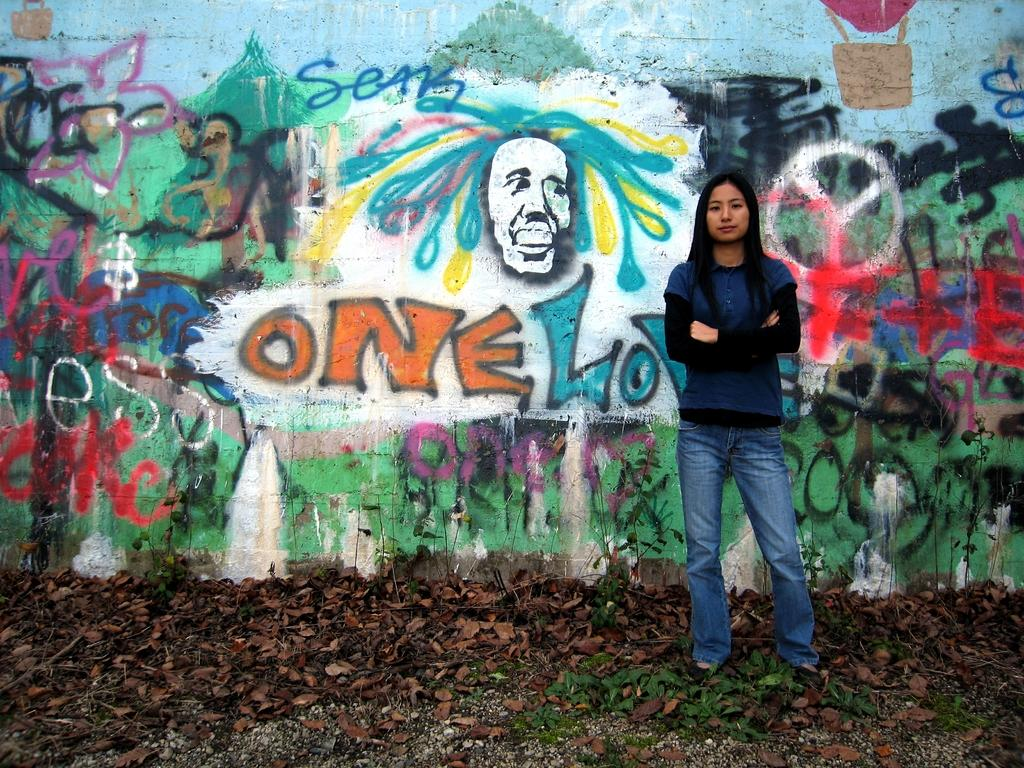What is the main subject in the image? There is a lady standing in the image. What can be seen in the background of the image? There is graffiti on a wall in the background of the image. What type of natural elements are present on the ground in the image? There are leaves on the ground in the image. What type of bubble can be seen floating near the lady in the image? There is no bubble present in the image. 